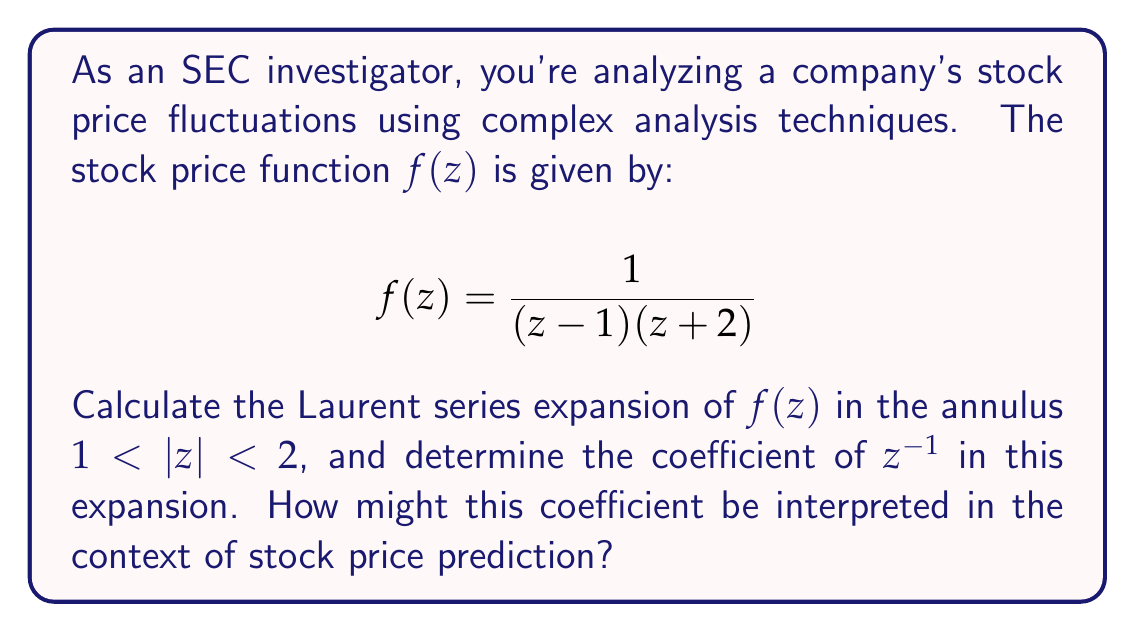Solve this math problem. To find the Laurent series expansion of $f(z)$ in the annulus $1 < |z| < 2$, we'll use partial fraction decomposition:

1) First, decompose $f(z)$:
   $$f(z) = \frac{1}{(z-1)(z+2)} = \frac{A}{z-1} + \frac{B}{z+2}$$

2) Find A and B:
   $$1 = A(z+2) + B(z-1)$$
   When $z=1$: $1 = A(3)$, so $A = \frac{1}{3}$
   When $z=-2$: $1 = B(-3)$, so $B = -\frac{1}{3}$

3) Therefore:
   $$f(z) = \frac{1/3}{z-1} - \frac{1/3}{z+2}$$

4) Now, expand each term as a geometric series:
   For $\frac{1/3}{z-1}$: $\frac{1/3}{z(1-\frac{1}{z})} = \frac{1}{3z}(1 + \frac{1}{z} + \frac{1}{z^2} + ...)$ (valid for $|z| > 1$)
   For $-\frac{1/3}{z+2}$: $-\frac{1/3}{z(1+\frac{2}{z})} = -\frac{1}{3z}(1 - \frac{2}{z} + \frac{4}{z^2} - ...)$ (valid for $|z| > 2$)

5) Combining these series:
   $$f(z) = \frac{1}{3z}(1 + \frac{1}{z} + \frac{1}{z^2} + ...) - \frac{1}{3z}(1 - \frac{2}{z} + \frac{4}{z^2} - ...)$$
   $$= \frac{1}{3z}(\frac{3}{z} - \frac{3}{z^2} + ...)$$
   $$= \frac{1}{z^2} - \frac{1}{z^3} + ...$$

6) The coefficient of $z^{-1}$ is 0.

In the context of stock price prediction, the coefficient of $z^{-1}$ often represents the trend component. A zero coefficient suggests no clear upward or downward trend in the stock price within the analyzed region, indicating potential stability or unpredictability in the short term.
Answer: 0 